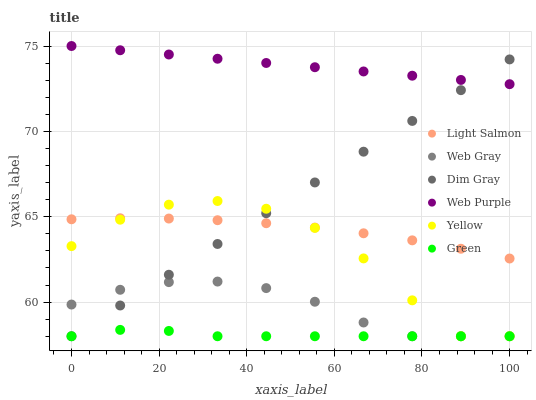Does Green have the minimum area under the curve?
Answer yes or no. Yes. Does Web Purple have the maximum area under the curve?
Answer yes or no. Yes. Does Web Gray have the minimum area under the curve?
Answer yes or no. No. Does Web Gray have the maximum area under the curve?
Answer yes or no. No. Is Dim Gray the smoothest?
Answer yes or no. Yes. Is Yellow the roughest?
Answer yes or no. Yes. Is Web Gray the smoothest?
Answer yes or no. No. Is Web Gray the roughest?
Answer yes or no. No. Does Web Gray have the lowest value?
Answer yes or no. Yes. Does Web Purple have the lowest value?
Answer yes or no. No. Does Web Purple have the highest value?
Answer yes or no. Yes. Does Web Gray have the highest value?
Answer yes or no. No. Is Green less than Web Purple?
Answer yes or no. Yes. Is Web Purple greater than Green?
Answer yes or no. Yes. Does Dim Gray intersect Yellow?
Answer yes or no. Yes. Is Dim Gray less than Yellow?
Answer yes or no. No. Is Dim Gray greater than Yellow?
Answer yes or no. No. Does Green intersect Web Purple?
Answer yes or no. No. 